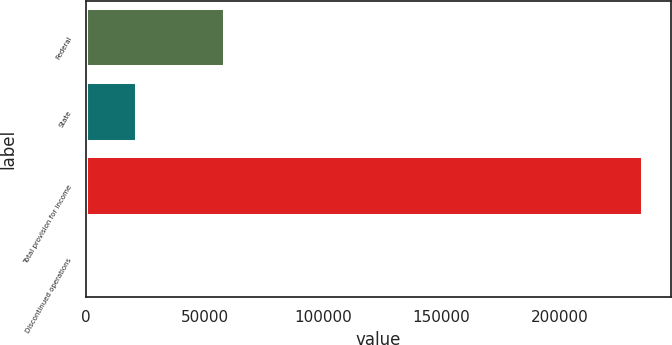<chart> <loc_0><loc_0><loc_500><loc_500><bar_chart><fcel>Federal<fcel>State<fcel>Total provision for income<fcel>Discontinued operations<nl><fcel>58844<fcel>21486<fcel>235092<fcel>114<nl></chart> 